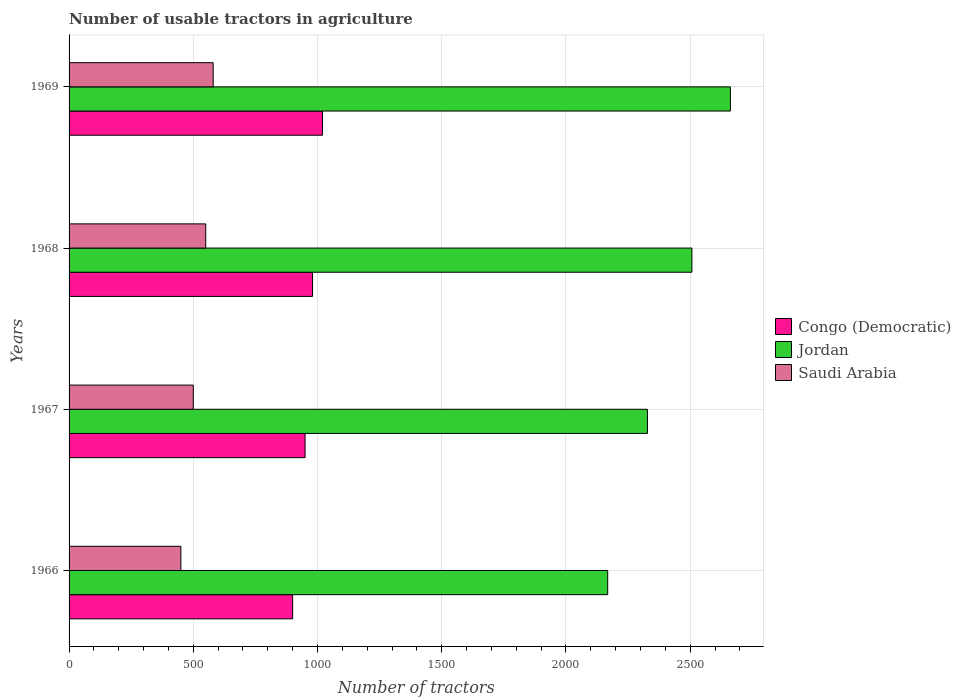Are the number of bars on each tick of the Y-axis equal?
Provide a short and direct response. Yes. How many bars are there on the 2nd tick from the top?
Provide a short and direct response. 3. What is the label of the 3rd group of bars from the top?
Your answer should be very brief. 1967. What is the number of usable tractors in agriculture in Saudi Arabia in 1968?
Your answer should be very brief. 550. Across all years, what is the maximum number of usable tractors in agriculture in Congo (Democratic)?
Make the answer very short. 1020. Across all years, what is the minimum number of usable tractors in agriculture in Jordan?
Provide a succinct answer. 2168. In which year was the number of usable tractors in agriculture in Saudi Arabia maximum?
Your answer should be compact. 1969. In which year was the number of usable tractors in agriculture in Congo (Democratic) minimum?
Your answer should be compact. 1966. What is the total number of usable tractors in agriculture in Jordan in the graph?
Provide a short and direct response. 9665. What is the difference between the number of usable tractors in agriculture in Congo (Democratic) in 1966 and that in 1969?
Ensure brevity in your answer.  -120. What is the difference between the number of usable tractors in agriculture in Congo (Democratic) in 1966 and the number of usable tractors in agriculture in Saudi Arabia in 1969?
Give a very brief answer. 320. What is the average number of usable tractors in agriculture in Jordan per year?
Ensure brevity in your answer.  2416.25. In the year 1966, what is the difference between the number of usable tractors in agriculture in Congo (Democratic) and number of usable tractors in agriculture in Jordan?
Your answer should be compact. -1268. What is the ratio of the number of usable tractors in agriculture in Saudi Arabia in 1966 to that in 1969?
Offer a terse response. 0.78. Is the number of usable tractors in agriculture in Saudi Arabia in 1966 less than that in 1969?
Provide a succinct answer. Yes. What is the difference between the highest and the lowest number of usable tractors in agriculture in Jordan?
Ensure brevity in your answer.  494. What does the 2nd bar from the top in 1969 represents?
Offer a terse response. Jordan. What does the 1st bar from the bottom in 1968 represents?
Provide a short and direct response. Congo (Democratic). How many bars are there?
Your answer should be compact. 12. Are all the bars in the graph horizontal?
Your answer should be very brief. Yes. How many years are there in the graph?
Your answer should be very brief. 4. What is the difference between two consecutive major ticks on the X-axis?
Give a very brief answer. 500. What is the title of the graph?
Offer a terse response. Number of usable tractors in agriculture. Does "High income: nonOECD" appear as one of the legend labels in the graph?
Your answer should be compact. No. What is the label or title of the X-axis?
Provide a short and direct response. Number of tractors. What is the Number of tractors in Congo (Democratic) in 1966?
Offer a terse response. 900. What is the Number of tractors in Jordan in 1966?
Your response must be concise. 2168. What is the Number of tractors of Saudi Arabia in 1966?
Your response must be concise. 450. What is the Number of tractors in Congo (Democratic) in 1967?
Provide a succinct answer. 950. What is the Number of tractors of Jordan in 1967?
Your response must be concise. 2328. What is the Number of tractors of Saudi Arabia in 1967?
Offer a very short reply. 500. What is the Number of tractors in Congo (Democratic) in 1968?
Your response must be concise. 980. What is the Number of tractors in Jordan in 1968?
Your answer should be very brief. 2507. What is the Number of tractors of Saudi Arabia in 1968?
Your response must be concise. 550. What is the Number of tractors of Congo (Democratic) in 1969?
Your answer should be compact. 1020. What is the Number of tractors in Jordan in 1969?
Your response must be concise. 2662. What is the Number of tractors in Saudi Arabia in 1969?
Your response must be concise. 580. Across all years, what is the maximum Number of tractors in Congo (Democratic)?
Provide a succinct answer. 1020. Across all years, what is the maximum Number of tractors in Jordan?
Provide a succinct answer. 2662. Across all years, what is the maximum Number of tractors in Saudi Arabia?
Give a very brief answer. 580. Across all years, what is the minimum Number of tractors in Congo (Democratic)?
Ensure brevity in your answer.  900. Across all years, what is the minimum Number of tractors of Jordan?
Provide a succinct answer. 2168. Across all years, what is the minimum Number of tractors in Saudi Arabia?
Offer a very short reply. 450. What is the total Number of tractors in Congo (Democratic) in the graph?
Your answer should be very brief. 3850. What is the total Number of tractors in Jordan in the graph?
Your response must be concise. 9665. What is the total Number of tractors of Saudi Arabia in the graph?
Keep it short and to the point. 2080. What is the difference between the Number of tractors of Congo (Democratic) in 1966 and that in 1967?
Keep it short and to the point. -50. What is the difference between the Number of tractors of Jordan in 1966 and that in 1967?
Your answer should be very brief. -160. What is the difference between the Number of tractors of Congo (Democratic) in 1966 and that in 1968?
Keep it short and to the point. -80. What is the difference between the Number of tractors in Jordan in 1966 and that in 1968?
Give a very brief answer. -339. What is the difference between the Number of tractors of Saudi Arabia in 1966 and that in 1968?
Make the answer very short. -100. What is the difference between the Number of tractors of Congo (Democratic) in 1966 and that in 1969?
Keep it short and to the point. -120. What is the difference between the Number of tractors in Jordan in 1966 and that in 1969?
Make the answer very short. -494. What is the difference between the Number of tractors in Saudi Arabia in 1966 and that in 1969?
Offer a terse response. -130. What is the difference between the Number of tractors in Jordan in 1967 and that in 1968?
Ensure brevity in your answer.  -179. What is the difference between the Number of tractors in Congo (Democratic) in 1967 and that in 1969?
Offer a terse response. -70. What is the difference between the Number of tractors of Jordan in 1967 and that in 1969?
Your answer should be compact. -334. What is the difference between the Number of tractors in Saudi Arabia in 1967 and that in 1969?
Make the answer very short. -80. What is the difference between the Number of tractors in Congo (Democratic) in 1968 and that in 1969?
Make the answer very short. -40. What is the difference between the Number of tractors of Jordan in 1968 and that in 1969?
Give a very brief answer. -155. What is the difference between the Number of tractors in Saudi Arabia in 1968 and that in 1969?
Your response must be concise. -30. What is the difference between the Number of tractors of Congo (Democratic) in 1966 and the Number of tractors of Jordan in 1967?
Keep it short and to the point. -1428. What is the difference between the Number of tractors of Jordan in 1966 and the Number of tractors of Saudi Arabia in 1967?
Offer a very short reply. 1668. What is the difference between the Number of tractors in Congo (Democratic) in 1966 and the Number of tractors in Jordan in 1968?
Provide a short and direct response. -1607. What is the difference between the Number of tractors of Congo (Democratic) in 1966 and the Number of tractors of Saudi Arabia in 1968?
Offer a very short reply. 350. What is the difference between the Number of tractors of Jordan in 1966 and the Number of tractors of Saudi Arabia in 1968?
Your answer should be very brief. 1618. What is the difference between the Number of tractors in Congo (Democratic) in 1966 and the Number of tractors in Jordan in 1969?
Make the answer very short. -1762. What is the difference between the Number of tractors of Congo (Democratic) in 1966 and the Number of tractors of Saudi Arabia in 1969?
Offer a very short reply. 320. What is the difference between the Number of tractors of Jordan in 1966 and the Number of tractors of Saudi Arabia in 1969?
Your answer should be compact. 1588. What is the difference between the Number of tractors of Congo (Democratic) in 1967 and the Number of tractors of Jordan in 1968?
Provide a succinct answer. -1557. What is the difference between the Number of tractors in Jordan in 1967 and the Number of tractors in Saudi Arabia in 1968?
Ensure brevity in your answer.  1778. What is the difference between the Number of tractors in Congo (Democratic) in 1967 and the Number of tractors in Jordan in 1969?
Your answer should be compact. -1712. What is the difference between the Number of tractors in Congo (Democratic) in 1967 and the Number of tractors in Saudi Arabia in 1969?
Make the answer very short. 370. What is the difference between the Number of tractors in Jordan in 1967 and the Number of tractors in Saudi Arabia in 1969?
Your response must be concise. 1748. What is the difference between the Number of tractors of Congo (Democratic) in 1968 and the Number of tractors of Jordan in 1969?
Offer a terse response. -1682. What is the difference between the Number of tractors of Congo (Democratic) in 1968 and the Number of tractors of Saudi Arabia in 1969?
Your response must be concise. 400. What is the difference between the Number of tractors in Jordan in 1968 and the Number of tractors in Saudi Arabia in 1969?
Give a very brief answer. 1927. What is the average Number of tractors in Congo (Democratic) per year?
Your answer should be compact. 962.5. What is the average Number of tractors in Jordan per year?
Ensure brevity in your answer.  2416.25. What is the average Number of tractors of Saudi Arabia per year?
Keep it short and to the point. 520. In the year 1966, what is the difference between the Number of tractors in Congo (Democratic) and Number of tractors in Jordan?
Give a very brief answer. -1268. In the year 1966, what is the difference between the Number of tractors of Congo (Democratic) and Number of tractors of Saudi Arabia?
Your answer should be compact. 450. In the year 1966, what is the difference between the Number of tractors in Jordan and Number of tractors in Saudi Arabia?
Ensure brevity in your answer.  1718. In the year 1967, what is the difference between the Number of tractors of Congo (Democratic) and Number of tractors of Jordan?
Offer a terse response. -1378. In the year 1967, what is the difference between the Number of tractors in Congo (Democratic) and Number of tractors in Saudi Arabia?
Keep it short and to the point. 450. In the year 1967, what is the difference between the Number of tractors of Jordan and Number of tractors of Saudi Arabia?
Your answer should be compact. 1828. In the year 1968, what is the difference between the Number of tractors of Congo (Democratic) and Number of tractors of Jordan?
Make the answer very short. -1527. In the year 1968, what is the difference between the Number of tractors of Congo (Democratic) and Number of tractors of Saudi Arabia?
Make the answer very short. 430. In the year 1968, what is the difference between the Number of tractors of Jordan and Number of tractors of Saudi Arabia?
Give a very brief answer. 1957. In the year 1969, what is the difference between the Number of tractors in Congo (Democratic) and Number of tractors in Jordan?
Offer a very short reply. -1642. In the year 1969, what is the difference between the Number of tractors of Congo (Democratic) and Number of tractors of Saudi Arabia?
Provide a short and direct response. 440. In the year 1969, what is the difference between the Number of tractors in Jordan and Number of tractors in Saudi Arabia?
Keep it short and to the point. 2082. What is the ratio of the Number of tractors of Congo (Democratic) in 1966 to that in 1967?
Make the answer very short. 0.95. What is the ratio of the Number of tractors of Jordan in 1966 to that in 1967?
Ensure brevity in your answer.  0.93. What is the ratio of the Number of tractors of Saudi Arabia in 1966 to that in 1967?
Your answer should be very brief. 0.9. What is the ratio of the Number of tractors of Congo (Democratic) in 1966 to that in 1968?
Give a very brief answer. 0.92. What is the ratio of the Number of tractors of Jordan in 1966 to that in 1968?
Make the answer very short. 0.86. What is the ratio of the Number of tractors in Saudi Arabia in 1966 to that in 1968?
Ensure brevity in your answer.  0.82. What is the ratio of the Number of tractors of Congo (Democratic) in 1966 to that in 1969?
Give a very brief answer. 0.88. What is the ratio of the Number of tractors in Jordan in 1966 to that in 1969?
Offer a terse response. 0.81. What is the ratio of the Number of tractors of Saudi Arabia in 1966 to that in 1969?
Give a very brief answer. 0.78. What is the ratio of the Number of tractors of Congo (Democratic) in 1967 to that in 1968?
Offer a terse response. 0.97. What is the ratio of the Number of tractors of Jordan in 1967 to that in 1968?
Provide a short and direct response. 0.93. What is the ratio of the Number of tractors in Congo (Democratic) in 1967 to that in 1969?
Give a very brief answer. 0.93. What is the ratio of the Number of tractors in Jordan in 1967 to that in 1969?
Your response must be concise. 0.87. What is the ratio of the Number of tractors of Saudi Arabia in 1967 to that in 1969?
Make the answer very short. 0.86. What is the ratio of the Number of tractors of Congo (Democratic) in 1968 to that in 1969?
Offer a very short reply. 0.96. What is the ratio of the Number of tractors of Jordan in 1968 to that in 1969?
Your answer should be very brief. 0.94. What is the ratio of the Number of tractors of Saudi Arabia in 1968 to that in 1969?
Offer a very short reply. 0.95. What is the difference between the highest and the second highest Number of tractors of Jordan?
Your response must be concise. 155. What is the difference between the highest and the second highest Number of tractors in Saudi Arabia?
Provide a short and direct response. 30. What is the difference between the highest and the lowest Number of tractors of Congo (Democratic)?
Your response must be concise. 120. What is the difference between the highest and the lowest Number of tractors of Jordan?
Offer a terse response. 494. What is the difference between the highest and the lowest Number of tractors of Saudi Arabia?
Offer a terse response. 130. 